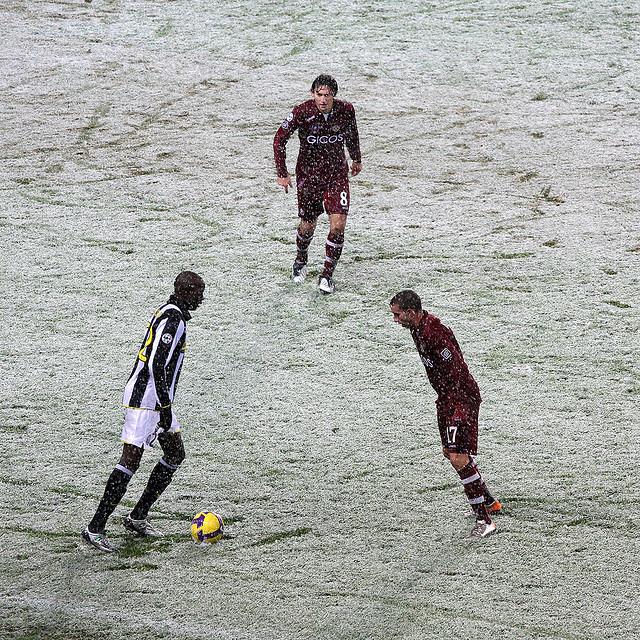What game are they playing?
Concise answer only. Soccer. Is it snowing?
Quick response, please. Yes. What are these children doing?
Keep it brief. Soccer. Why does the players shirt say Adidas?
Be succinct. Sponsor. 